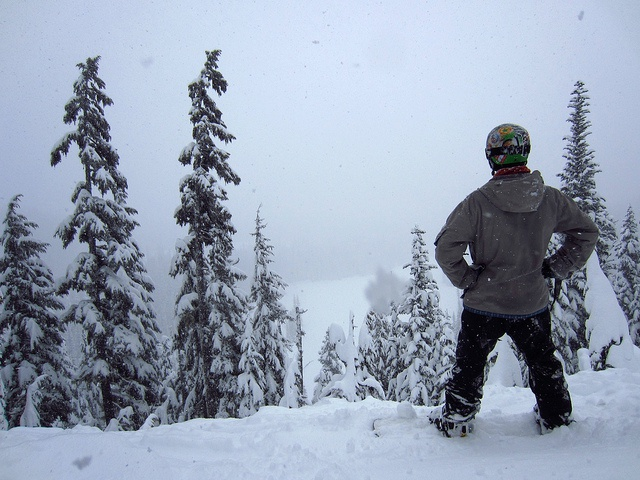Describe the objects in this image and their specific colors. I can see people in darkgray, black, and gray tones, snowboard in darkgray and gray tones, and snowboard in darkgray, lightgray, and gray tones in this image. 